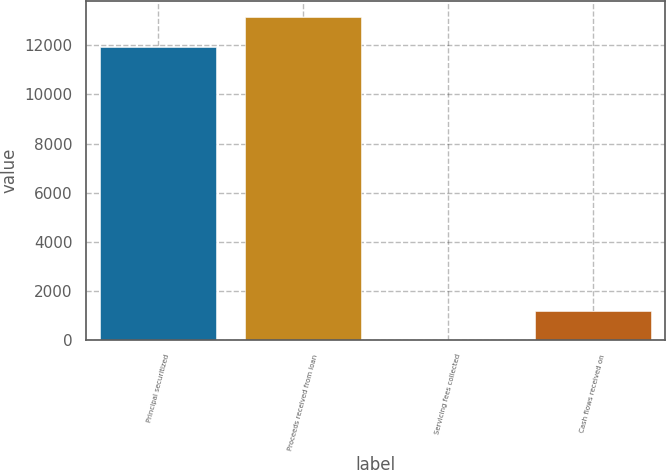Convert chart. <chart><loc_0><loc_0><loc_500><loc_500><bar_chart><fcel>Principal securitized<fcel>Proceeds received from loan<fcel>Servicing fees collected<fcel>Cash flows received on<nl><fcel>11933<fcel>13133.8<fcel>3<fcel>1203.8<nl></chart> 